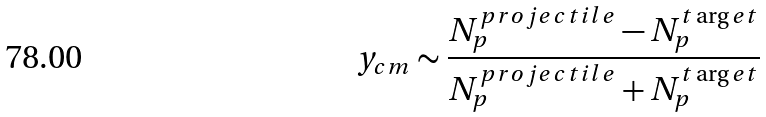Convert formula to latex. <formula><loc_0><loc_0><loc_500><loc_500>y _ { c m } \sim \frac { N _ { p } ^ { p r o j e c t i l e } - N _ { p } ^ { t \arg e t } } { N _ { p } ^ { p r o j e c t i l e } + N _ { p } ^ { t \arg e t } }</formula> 